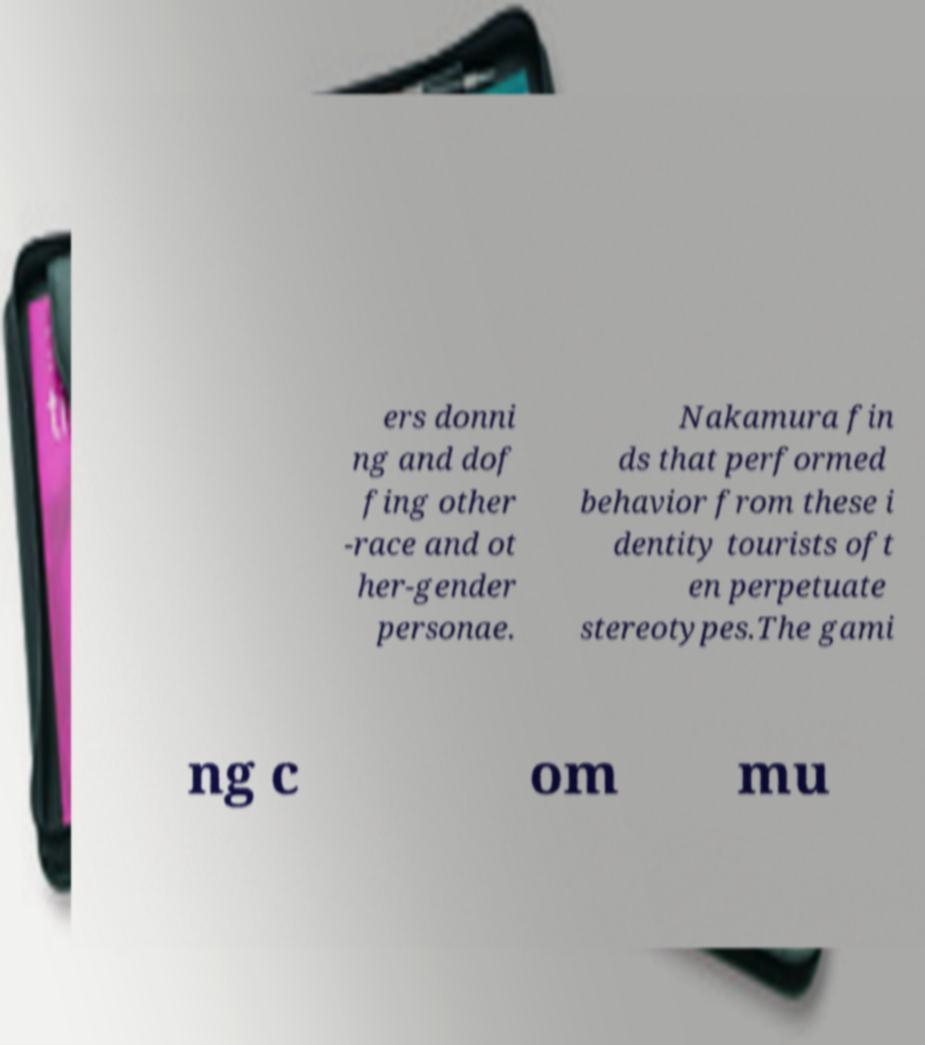Could you assist in decoding the text presented in this image and type it out clearly? ers donni ng and dof fing other -race and ot her-gender personae. Nakamura fin ds that performed behavior from these i dentity tourists oft en perpetuate stereotypes.The gami ng c om mu 